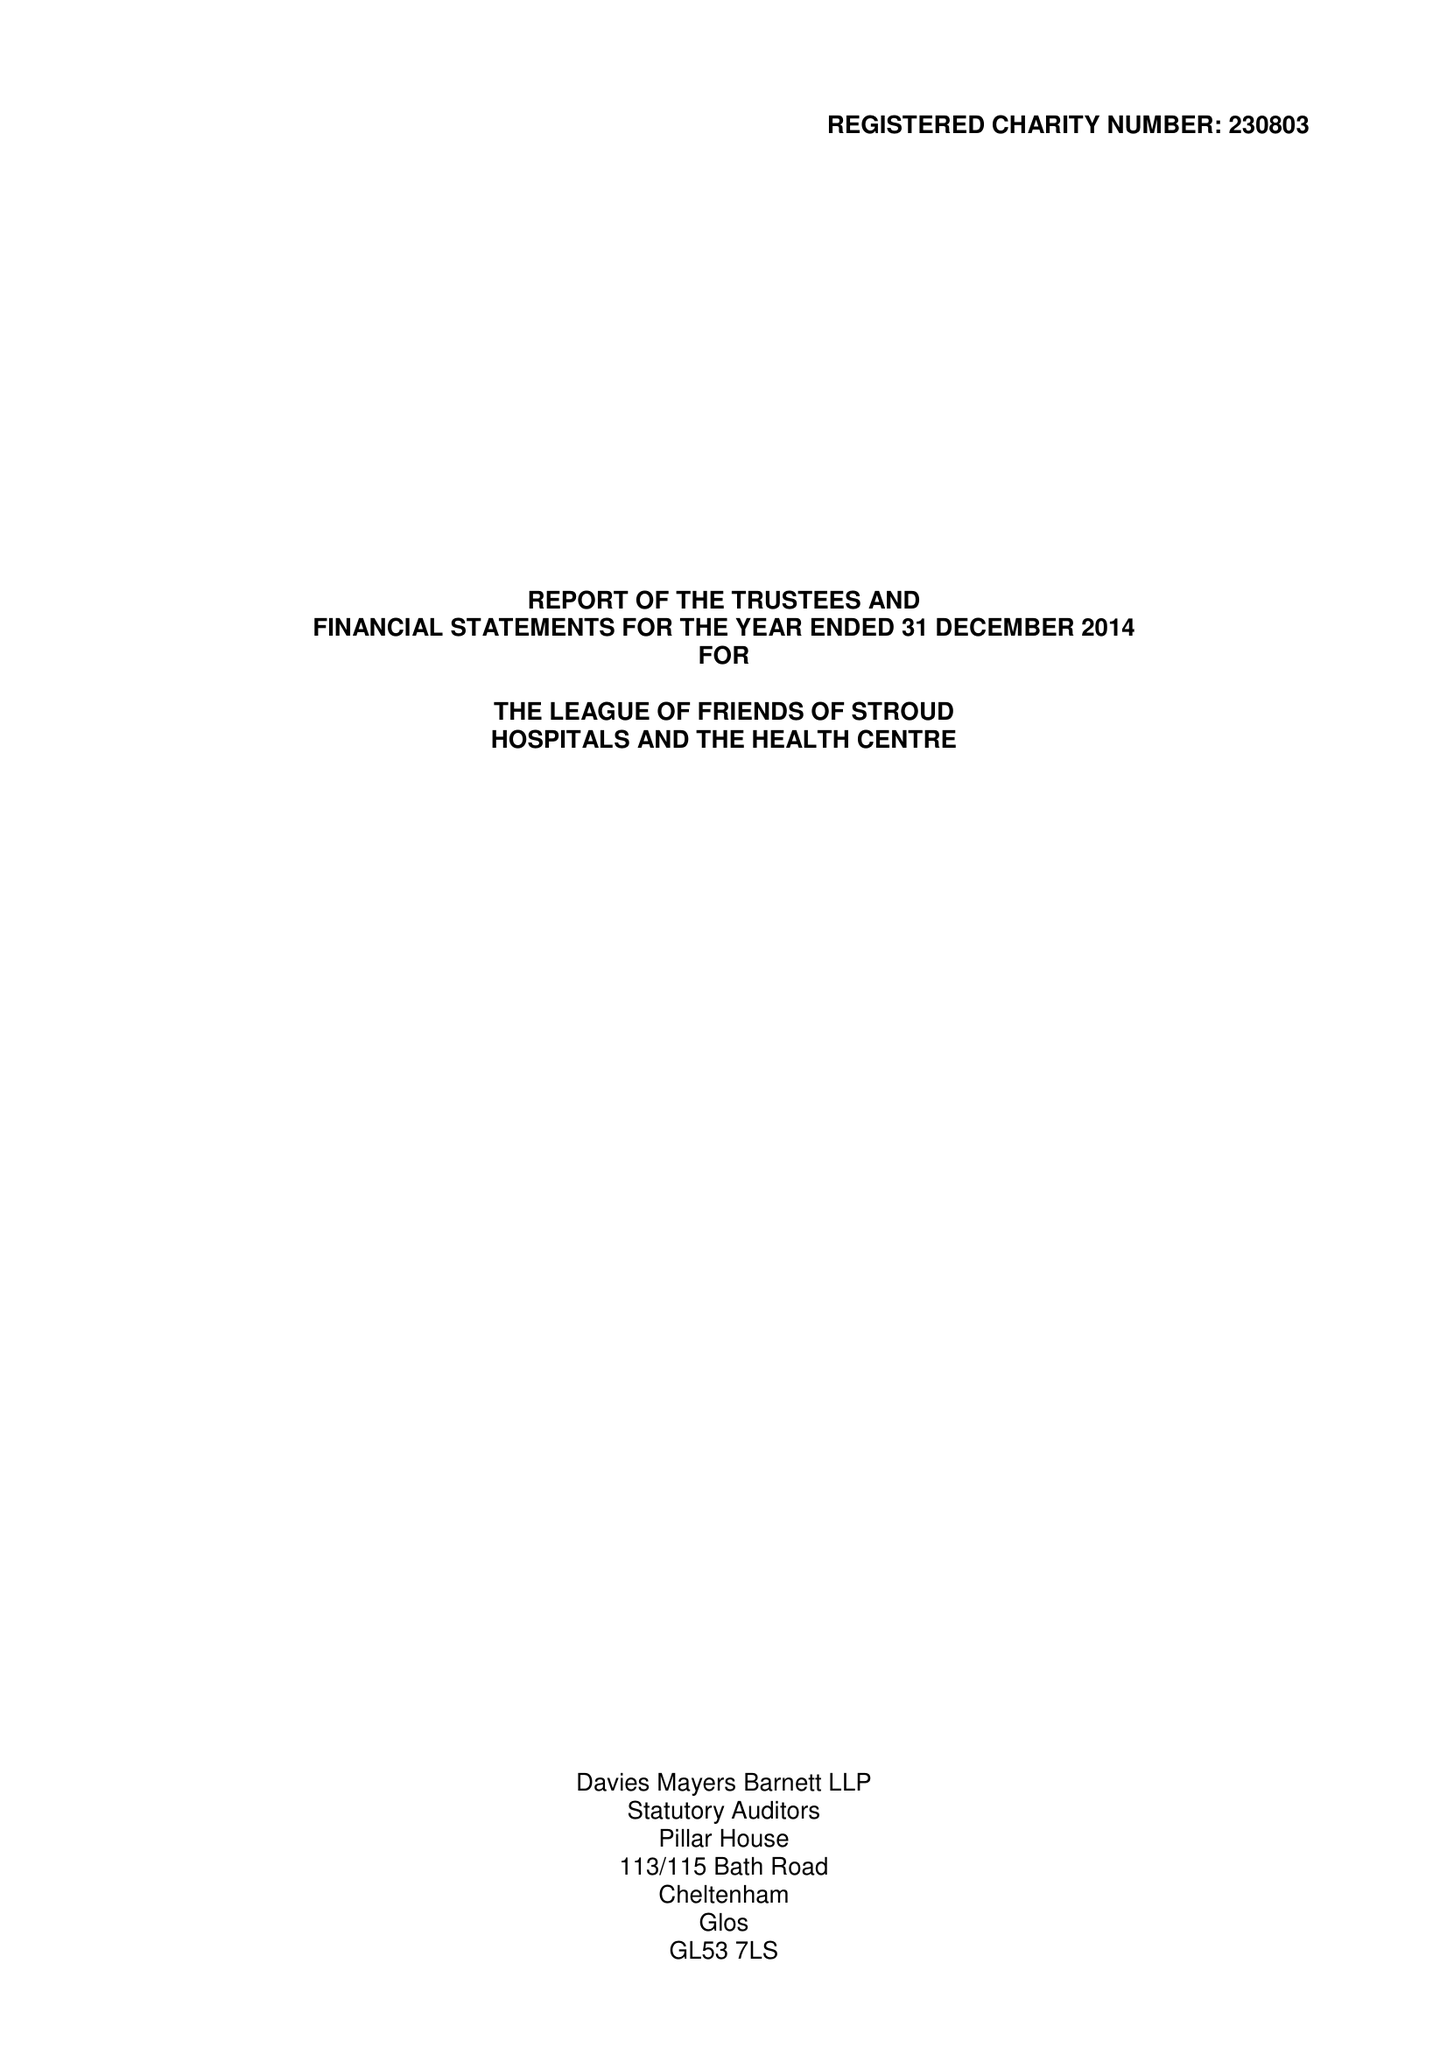What is the value for the address__postcode?
Answer the question using a single word or phrase. GL5 2HY 